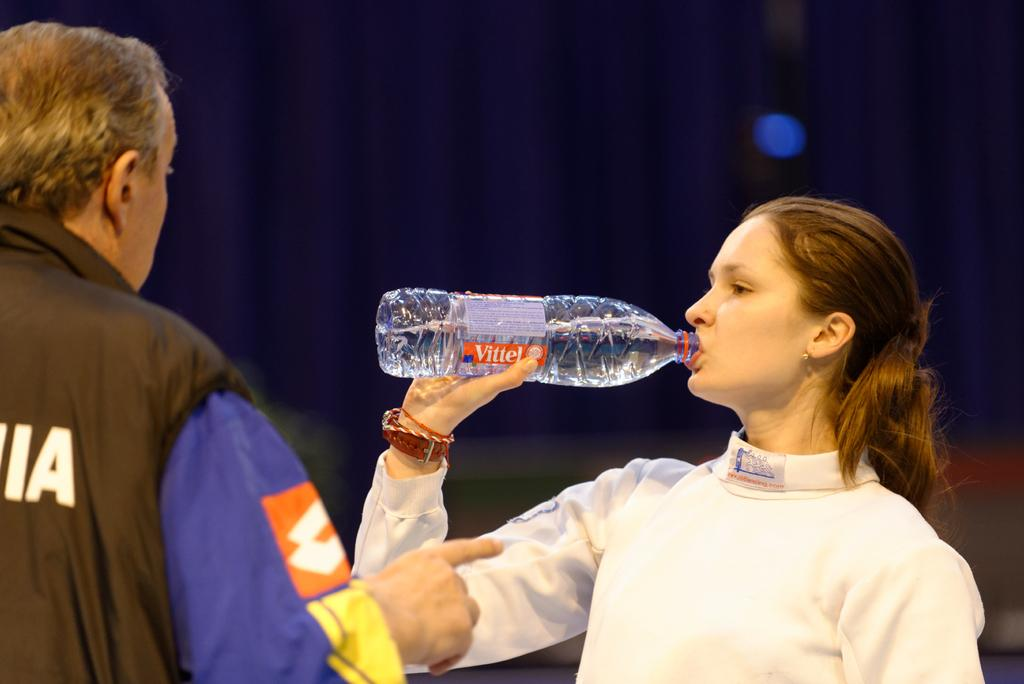<image>
Render a clear and concise summary of the photo. A man and a women in a room facing each other where the women is drinking a bottle of Vittel. 